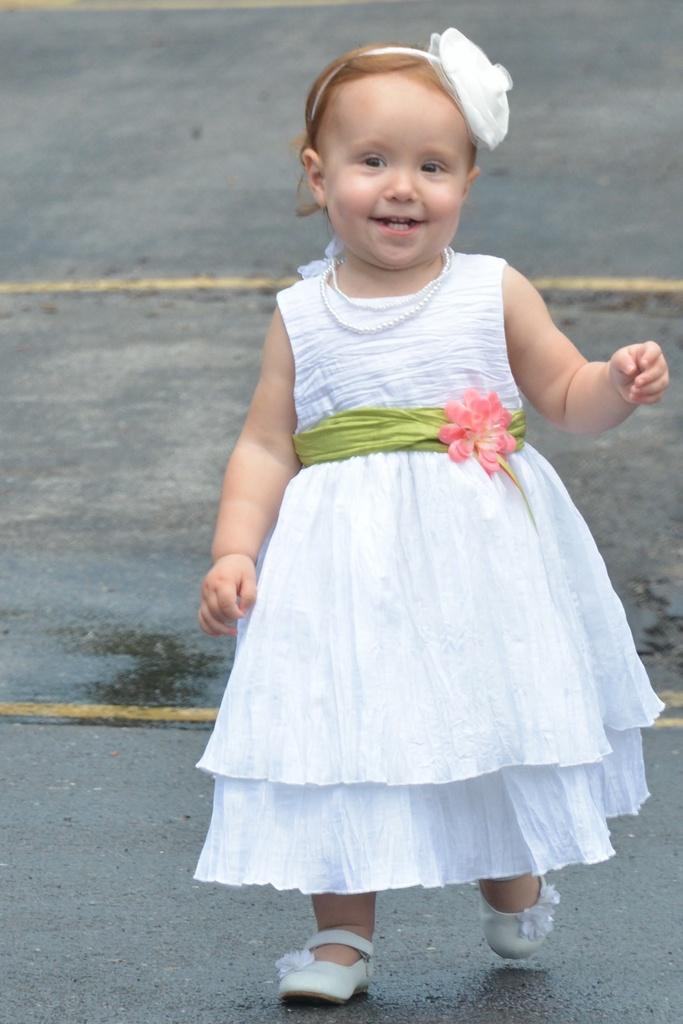Please provide a concise description of this image. In this picture I can see the path on which there are 2 lines and in front I see a girl who is wearing white color dress and I see necklace around her neck and I see hair band on her hair and I see that she is wearing white color shoes. 